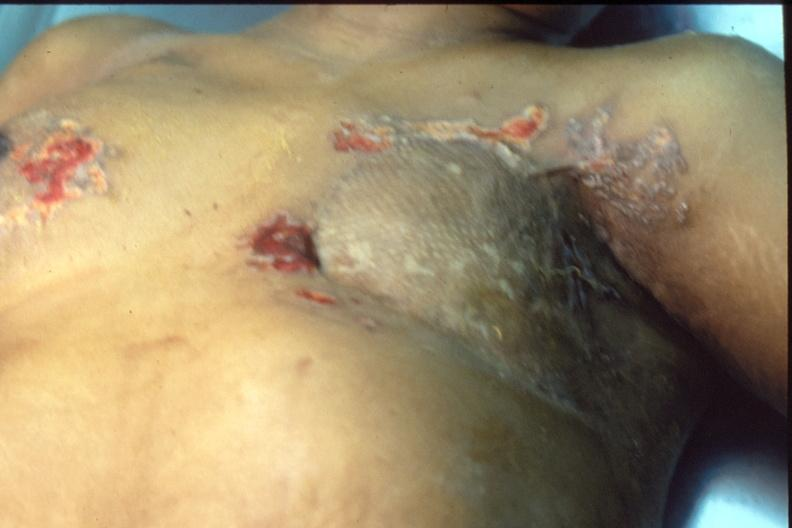where is this area in the body?
Answer the question using a single word or phrase. Breast 